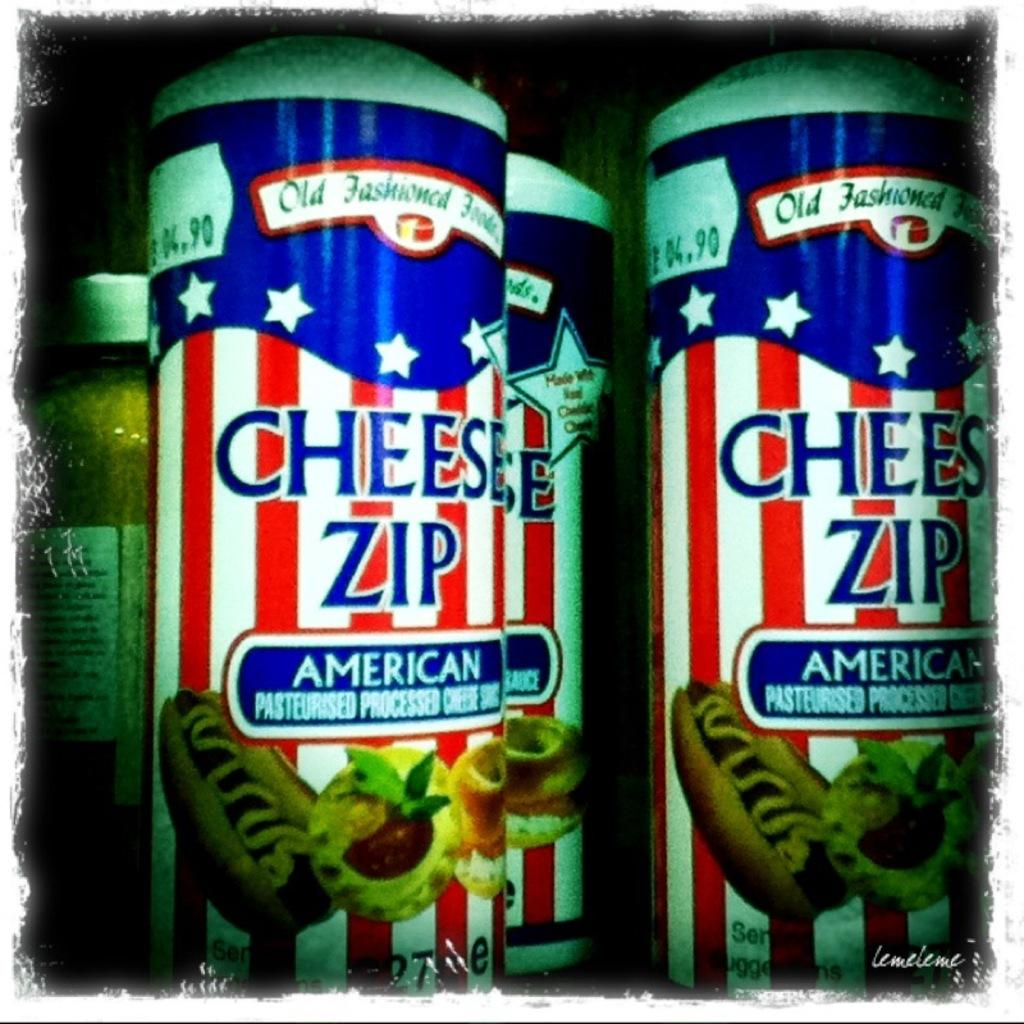<image>
Present a compact description of the photo's key features. Cans of Cheese Zip have pictures of hot dogs on them. 